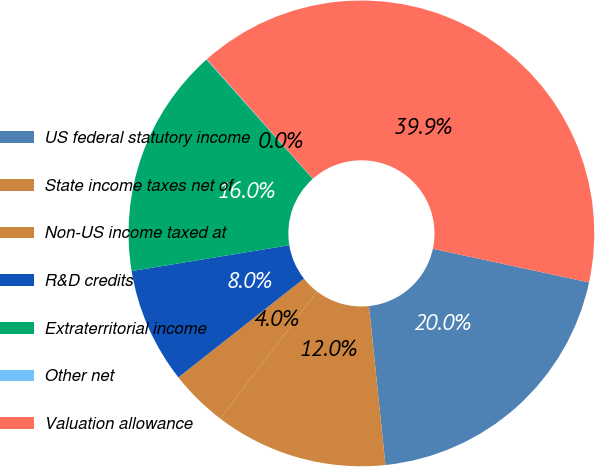Convert chart to OTSL. <chart><loc_0><loc_0><loc_500><loc_500><pie_chart><fcel>US federal statutory income<fcel>State income taxes net of<fcel>Non-US income taxed at<fcel>R&D credits<fcel>Extraterritorial income<fcel>Other net<fcel>Valuation allowance<nl><fcel>19.98%<fcel>12.01%<fcel>4.03%<fcel>8.02%<fcel>16.0%<fcel>0.04%<fcel>39.93%<nl></chart> 